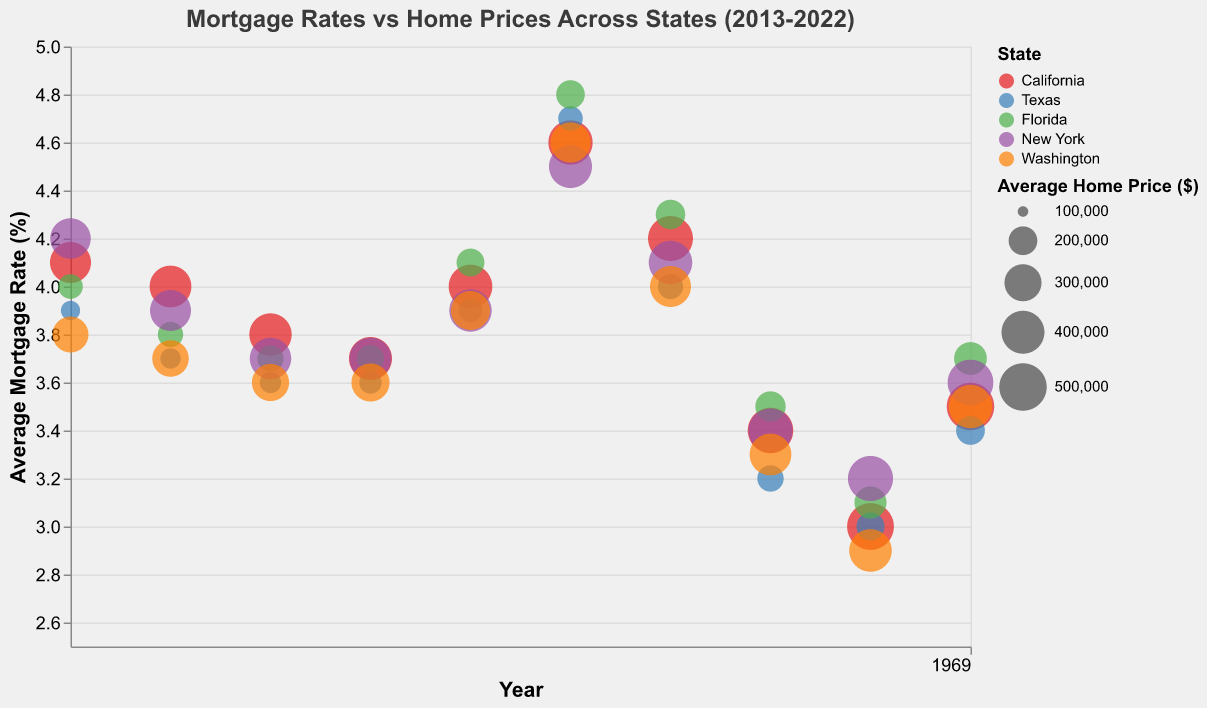What's the highest average home price for California in 2022? Look at the bubble corresponding to California in 2022 and observe the size, which indicates the average home price. The tooltip shows the exact value of $499,800.
Answer: $499,800 Which state had the lowest average mortgage rate in 2021, and what was the rate? Check the y-axis position of the bubbles for each state in 2021. Washington has the lowest position, indicating the lowest average mortgage rate of 2.9%.
Answer: Washington, 2.9% How did the average mortgage rate in Texas change from 2018 to 2020? Locate the bubbles for Texas in 2018 and 2020 on the x-axis and compare their y-axis positions. In 2018, the rate was 4.7%, and in 2020, it was 3.2%, a decrease of 1.5%.
Answer: Decreased by 1.5% Compare the average home prices of New York and Florida in 2018. Which state had a higher price and by how much? Find the bubbles for New York and Florida in 2018 and compare the size. New York's average home price was $402,100, while Florida's was $199,300. The difference is $402,100 - $199,300 = $202,800, with New York being higher.
Answer: New York, $202,800 What is the trend in average mortgage rates for California from 2013 to 2022? Observe the y-axis positions of California bubbles across the timeline on the x-axis. Start at 4.1% in 2013, fluctuate slightly, peaked at 4.6% in 2018, then decreased to 3.0% in 2021, and slightly increased to 3.5% in 2022. This indicates a general trend of initial stability, followed by a peak and subsequent decline.
Answer: Peak and decline Which state had the highest increase in average home prices from 2019 to 2022? Compare the size difference of bubbles for each state from 2019 to 2022. Washington saw an increase from $362,700 in 2019 to $409,200 in 2022, a difference of $46,500; compare this with changes for other states. Washington has a higher increase compared to others like Texas ($30,100), Florida ($35,200), New York ($48,800), and California ($58,300). The highest increase is in California.
Answer: California What's the average mortgage rate for New York across the decade? Identify New York's bubbles from 2013 to 2022, note their y-axis positions, sum the rates (4.2% + 3.9% + 3.7% + 3.7% + 3.9% + 4.5% + 4.1% + 3.4% + 3.2% + 3.6% = 38.2%) and divide by the number of years (10).
Answer: 3.82% In 2021, which state had the highest average home price, and what were the rates for mortgage there? Find 2021 bubbles on the x-axis and compare sizes. California's bubble is largest with an average home price of $485,200. The tooltip reveals its mortgage rate is 3.0%.
Answer: California, 3.0% How did the average mortgage rate and home prices in Florida evolve between 2013 and 2022? Observe Florida’s bubbles from 2013 to 2022. Mortgage rates start at 4.0%, fluctuate slightly, peak at 4.8% in 2018, decrease to 3.1% in 2021, and increase to 3.7% in 2022. Average home prices increase consistently from $165,800 in 2013 to $242,800 in 2022. This indicates general increasing trends for both metrics with some rate fluctuations.
Answer: Increasing with fluctuation 